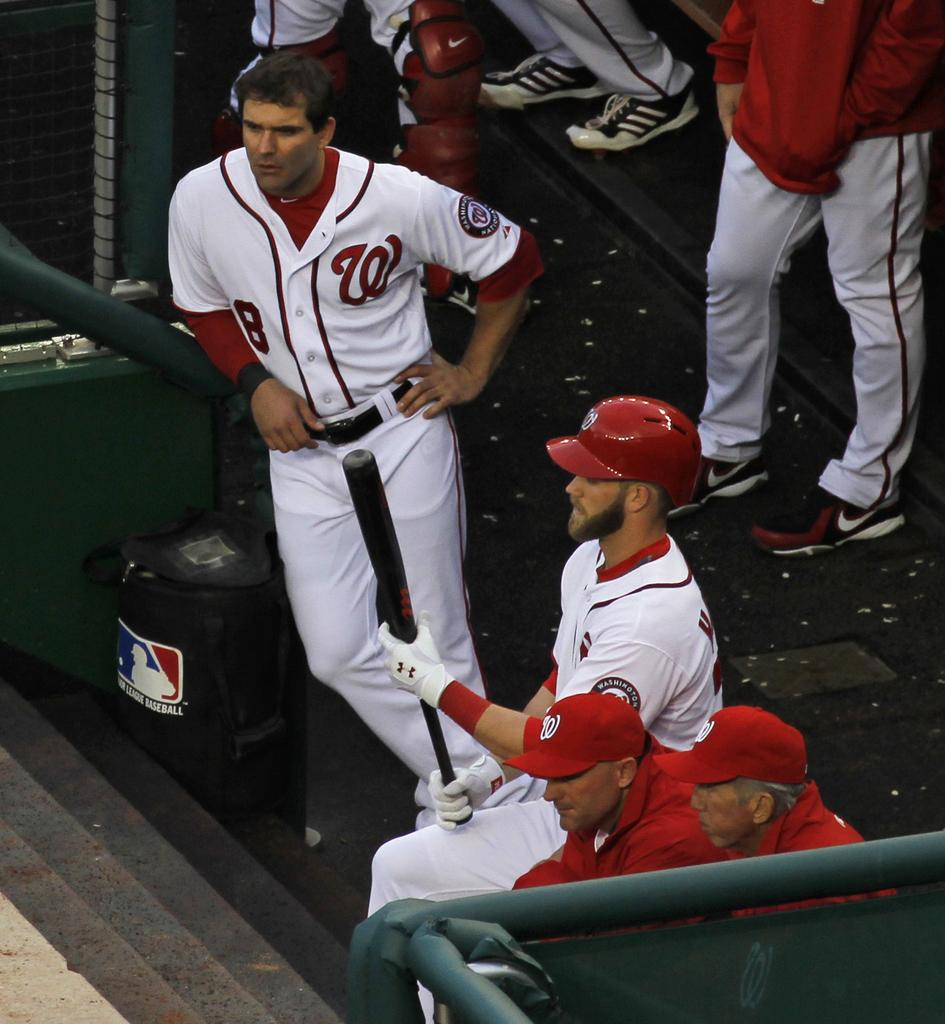<image>
Describe the image concisely. A player with a W on his shirt leans on a railing in the dugout. 